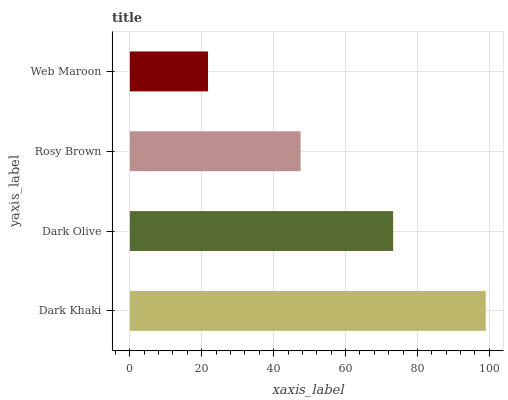Is Web Maroon the minimum?
Answer yes or no. Yes. Is Dark Khaki the maximum?
Answer yes or no. Yes. Is Dark Olive the minimum?
Answer yes or no. No. Is Dark Olive the maximum?
Answer yes or no. No. Is Dark Khaki greater than Dark Olive?
Answer yes or no. Yes. Is Dark Olive less than Dark Khaki?
Answer yes or no. Yes. Is Dark Olive greater than Dark Khaki?
Answer yes or no. No. Is Dark Khaki less than Dark Olive?
Answer yes or no. No. Is Dark Olive the high median?
Answer yes or no. Yes. Is Rosy Brown the low median?
Answer yes or no. Yes. Is Rosy Brown the high median?
Answer yes or no. No. Is Dark Khaki the low median?
Answer yes or no. No. 